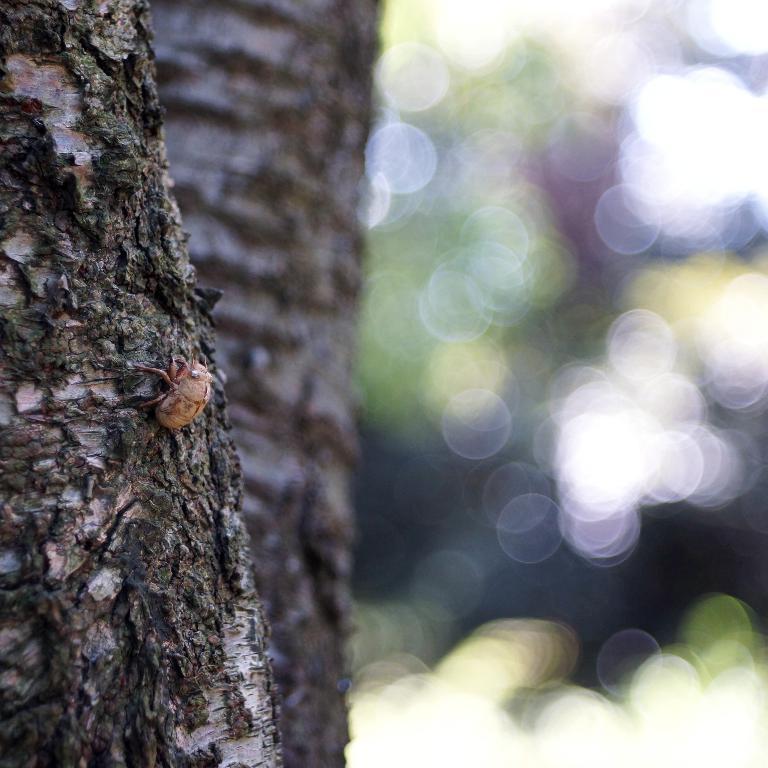Please provide a concise description of this image. In this image on the left side there is a tree, on the tree there is an insect and there is a blurry background. 